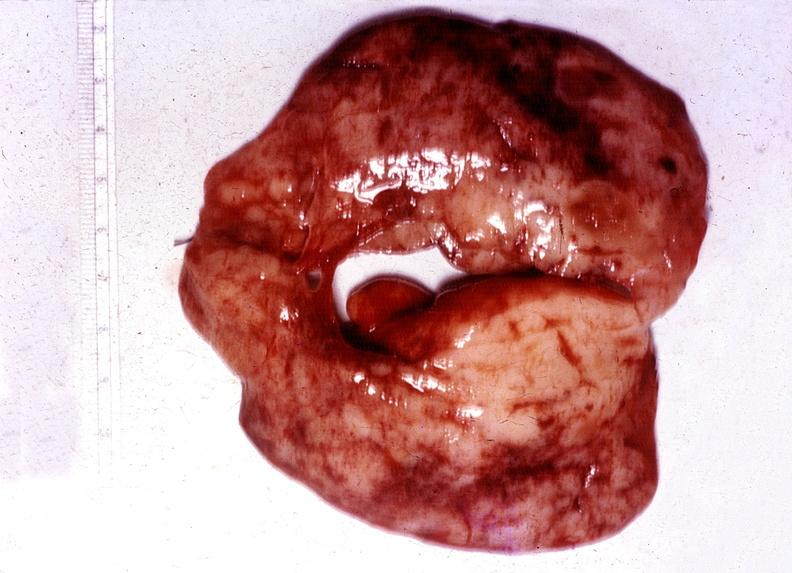what is present?
Answer the question using a single word or phrase. Endocrine 